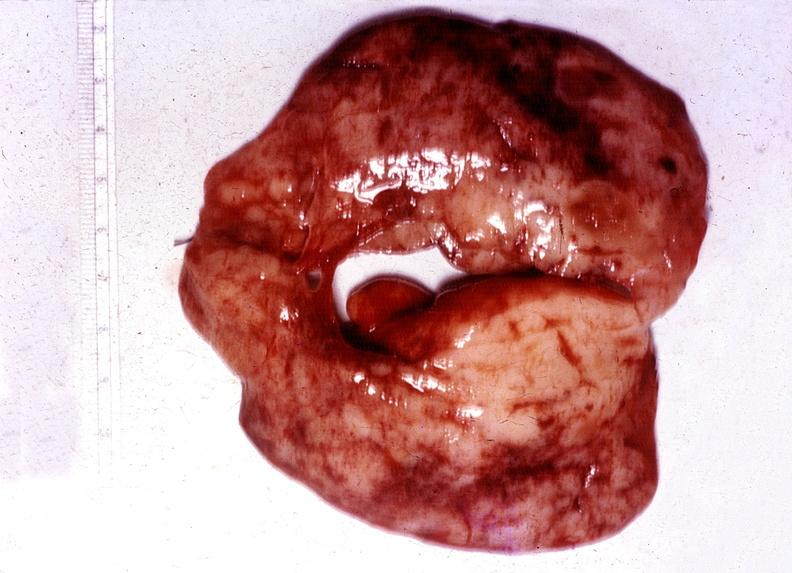what is present?
Answer the question using a single word or phrase. Endocrine 